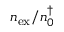Convert formula to latex. <formula><loc_0><loc_0><loc_500><loc_500>n _ { e x } / n _ { 0 } ^ { \dagger }</formula> 